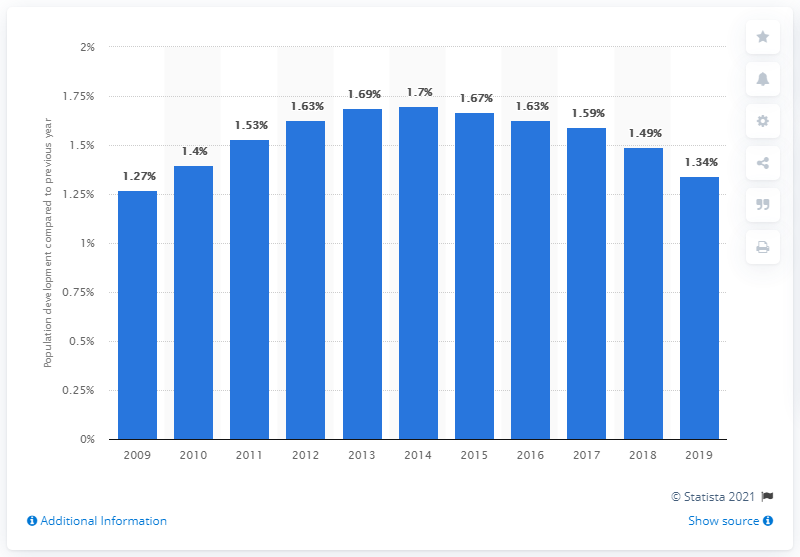List a handful of essential elements in this visual. In 2019, Turkey's population grew by 1.34%. 